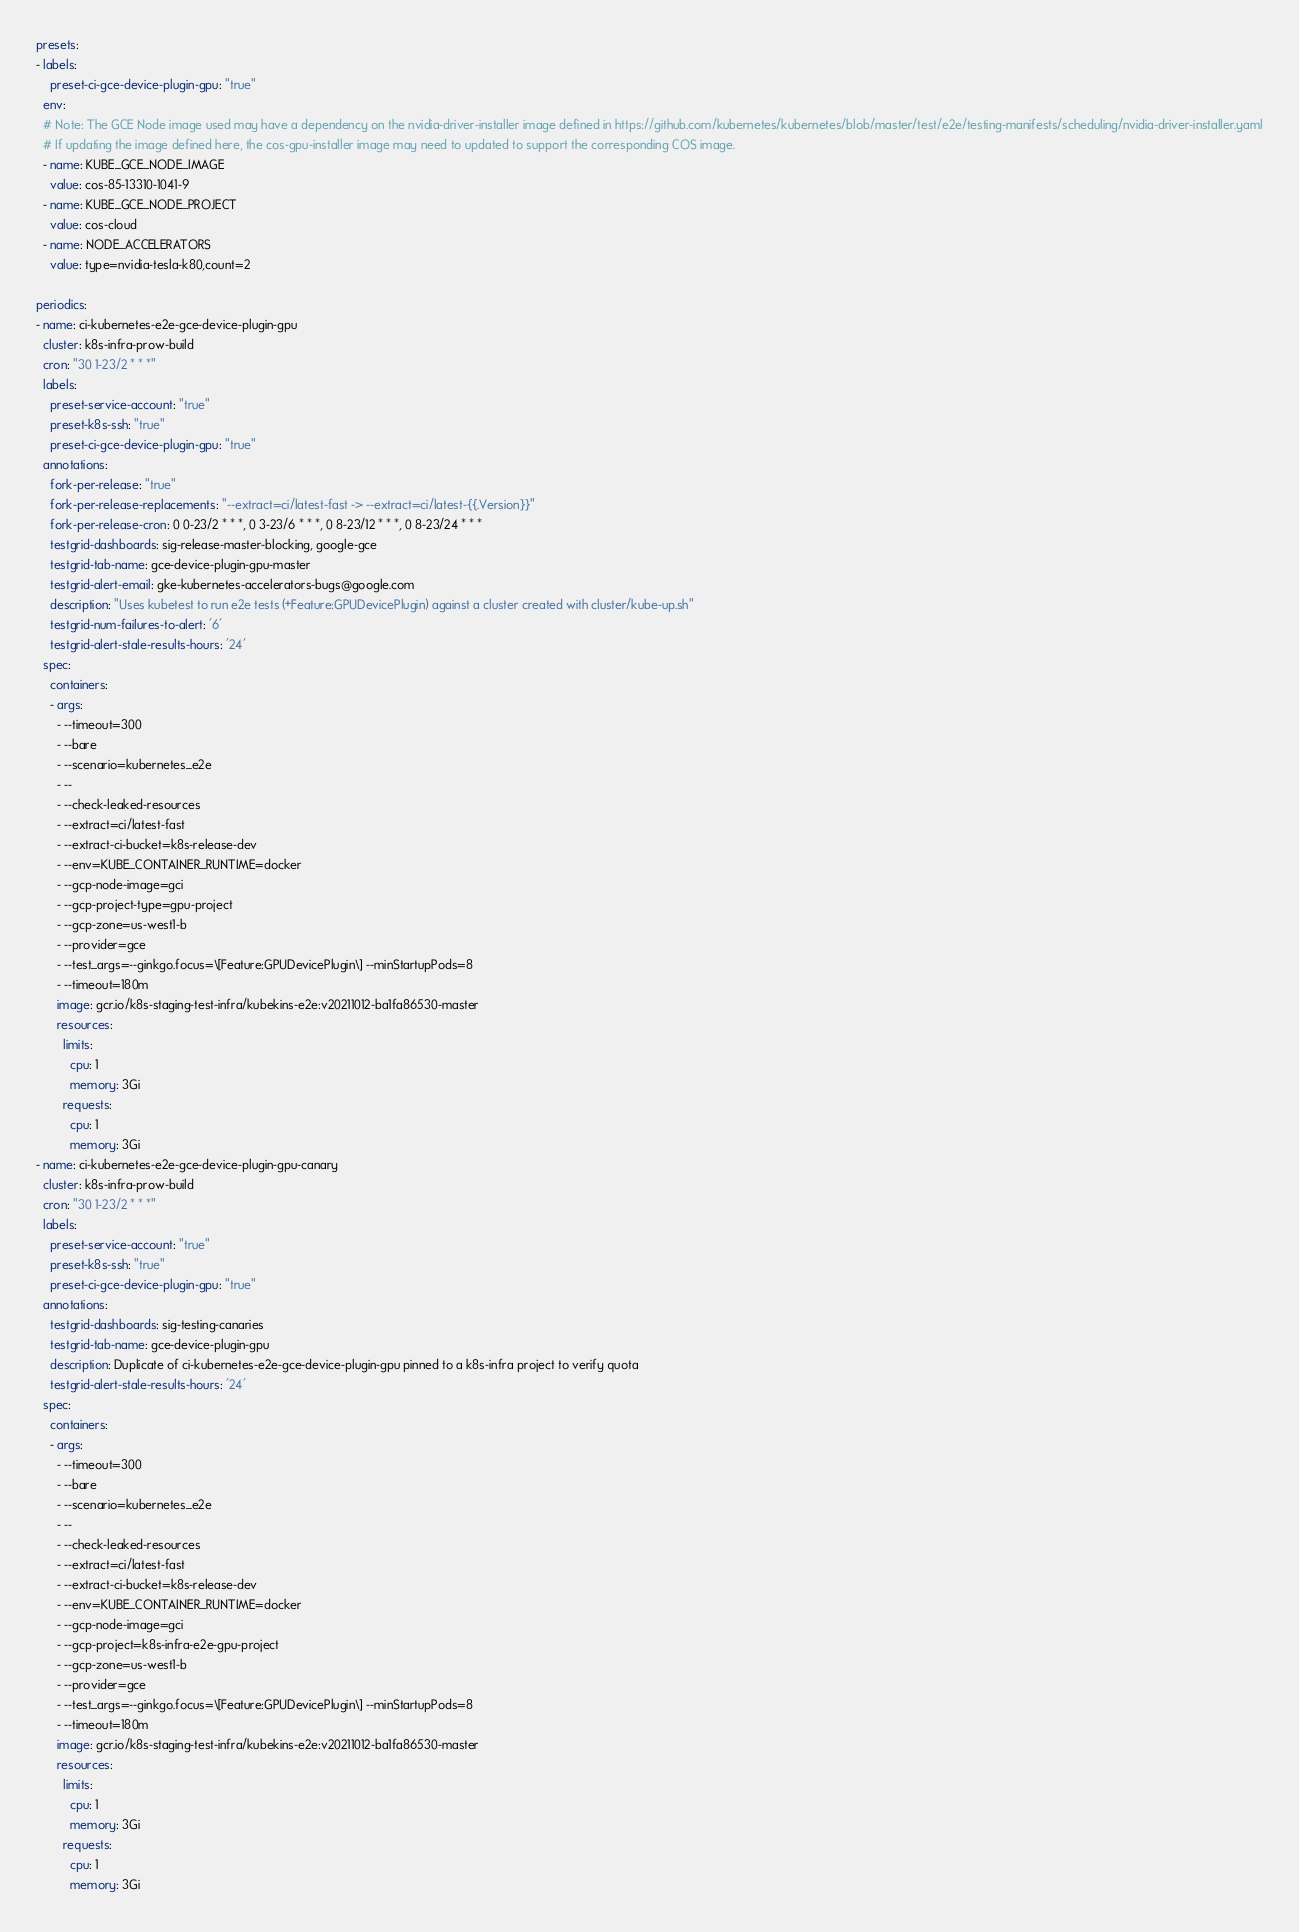<code> <loc_0><loc_0><loc_500><loc_500><_YAML_>presets:
- labels:
    preset-ci-gce-device-plugin-gpu: "true"
  env:
  # Note: The GCE Node image used may have a dependency on the nvidia-driver-installer image defined in https://github.com/kubernetes/kubernetes/blob/master/test/e2e/testing-manifests/scheduling/nvidia-driver-installer.yaml
  # If updating the image defined here, the cos-gpu-installer image may need to updated to support the corresponding COS image.
  - name: KUBE_GCE_NODE_IMAGE
    value: cos-85-13310-1041-9
  - name: KUBE_GCE_NODE_PROJECT
    value: cos-cloud
  - name: NODE_ACCELERATORS
    value: type=nvidia-tesla-k80,count=2

periodics:
- name: ci-kubernetes-e2e-gce-device-plugin-gpu
  cluster: k8s-infra-prow-build
  cron: "30 1-23/2 * * *"
  labels:
    preset-service-account: "true"
    preset-k8s-ssh: "true"
    preset-ci-gce-device-plugin-gpu: "true"
  annotations:
    fork-per-release: "true"
    fork-per-release-replacements: "--extract=ci/latest-fast -> --extract=ci/latest-{{.Version}}"
    fork-per-release-cron: 0 0-23/2 * * *, 0 3-23/6 * * *, 0 8-23/12 * * *, 0 8-23/24 * * *
    testgrid-dashboards: sig-release-master-blocking, google-gce
    testgrid-tab-name: gce-device-plugin-gpu-master
    testgrid-alert-email: gke-kubernetes-accelerators-bugs@google.com
    description: "Uses kubetest to run e2e tests (+Feature:GPUDevicePlugin) against a cluster created with cluster/kube-up.sh"
    testgrid-num-failures-to-alert: '6'
    testgrid-alert-stale-results-hours: '24'
  spec:
    containers:
    - args:
      - --timeout=300
      - --bare
      - --scenario=kubernetes_e2e
      - --
      - --check-leaked-resources
      - --extract=ci/latest-fast
      - --extract-ci-bucket=k8s-release-dev
      - --env=KUBE_CONTAINER_RUNTIME=docker
      - --gcp-node-image=gci
      - --gcp-project-type=gpu-project
      - --gcp-zone=us-west1-b
      - --provider=gce
      - --test_args=--ginkgo.focus=\[Feature:GPUDevicePlugin\] --minStartupPods=8
      - --timeout=180m
      image: gcr.io/k8s-staging-test-infra/kubekins-e2e:v20211012-ba1fa86530-master
      resources:
        limits:
          cpu: 1
          memory: 3Gi
        requests:
          cpu: 1
          memory: 3Gi
- name: ci-kubernetes-e2e-gce-device-plugin-gpu-canary
  cluster: k8s-infra-prow-build
  cron: "30 1-23/2 * * *"
  labels:
    preset-service-account: "true"
    preset-k8s-ssh: "true"
    preset-ci-gce-device-plugin-gpu: "true"
  annotations:
    testgrid-dashboards: sig-testing-canaries
    testgrid-tab-name: gce-device-plugin-gpu
    description: Duplicate of ci-kubernetes-e2e-gce-device-plugin-gpu pinned to a k8s-infra project to verify quota
    testgrid-alert-stale-results-hours: '24'
  spec:
    containers:
    - args:
      - --timeout=300
      - --bare
      - --scenario=kubernetes_e2e
      - --
      - --check-leaked-resources
      - --extract=ci/latest-fast
      - --extract-ci-bucket=k8s-release-dev
      - --env=KUBE_CONTAINER_RUNTIME=docker
      - --gcp-node-image=gci
      - --gcp-project=k8s-infra-e2e-gpu-project
      - --gcp-zone=us-west1-b
      - --provider=gce
      - --test_args=--ginkgo.focus=\[Feature:GPUDevicePlugin\] --minStartupPods=8
      - --timeout=180m
      image: gcr.io/k8s-staging-test-infra/kubekins-e2e:v20211012-ba1fa86530-master
      resources:
        limits:
          cpu: 1
          memory: 3Gi
        requests:
          cpu: 1
          memory: 3Gi
</code> 